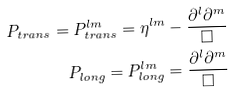<formula> <loc_0><loc_0><loc_500><loc_500>P _ { t r a n s } = P _ { t r a n s } ^ { l m } = \eta ^ { l m } - \frac { \partial ^ { l } \partial ^ { m } } { \square } \\ P _ { l o n g } = P _ { l o n g } ^ { l m } = \frac { \partial ^ { l } \partial ^ { m } } { \square }</formula> 